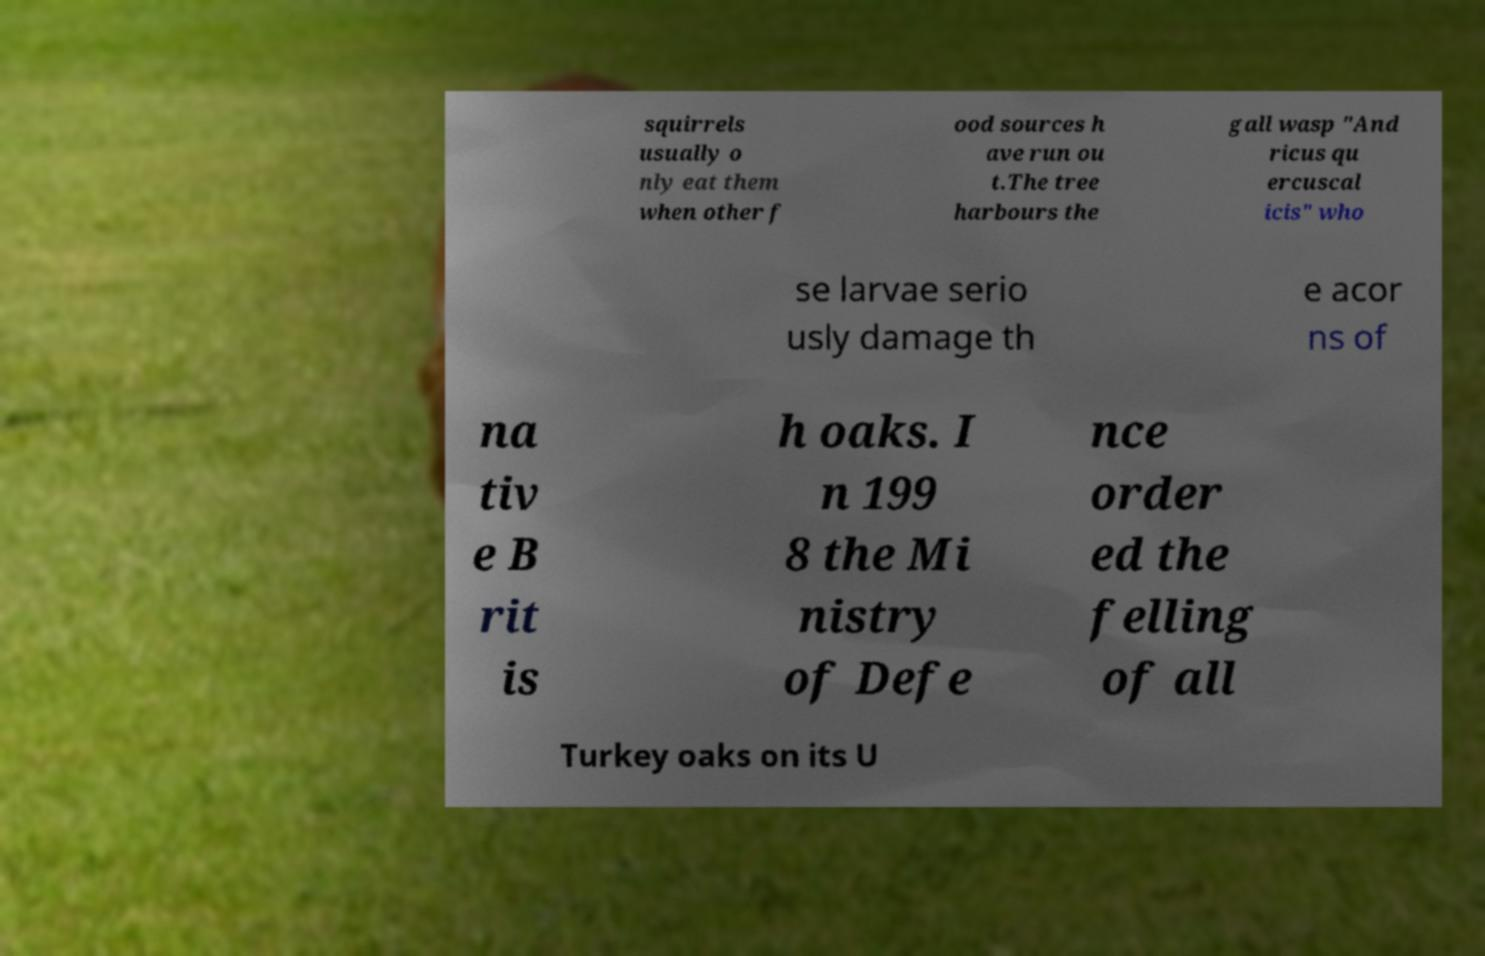Please read and relay the text visible in this image. What does it say? squirrels usually o nly eat them when other f ood sources h ave run ou t.The tree harbours the gall wasp "And ricus qu ercuscal icis" who se larvae serio usly damage th e acor ns of na tiv e B rit is h oaks. I n 199 8 the Mi nistry of Defe nce order ed the felling of all Turkey oaks on its U 